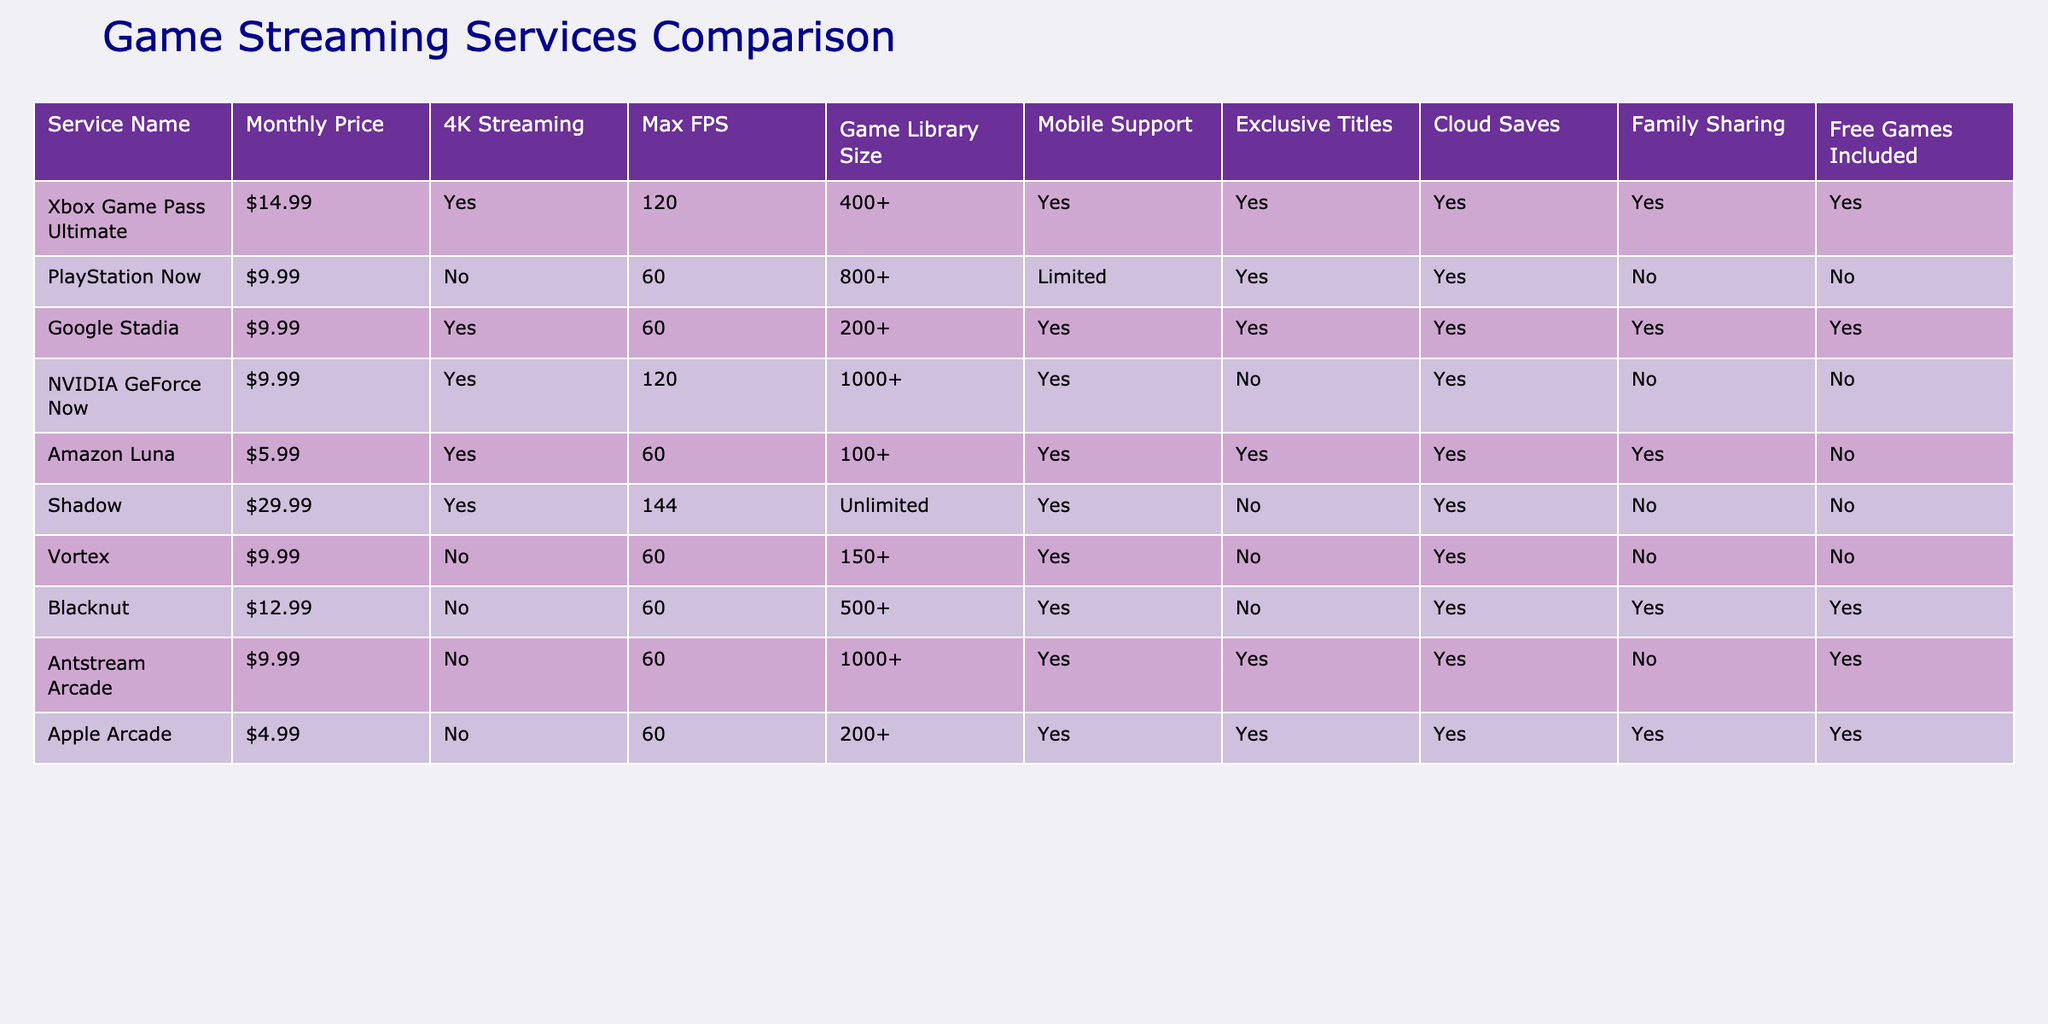What is the monthly price of NVIDIA GeForce Now? The table shows the monthly price for each service. According to the table, NVIDIA GeForce Now is listed at $9.99.
Answer: $9.99 Which service offers the largest game library size? The table provides the game library size for each service. By comparing the values, PlayStation Now has the largest game library with 800+.
Answer: PlayStation Now Does Amazon Luna support family sharing? Looking at the column for family sharing, it indicates whether each service supports this feature. Amazon Luna is marked with a "No", meaning it does not support family sharing.
Answer: No What are the average max FPS of services that offer 4K streaming? First, identify the services that offer 4K streaming: Xbox Game Pass Ultimate, Google Stadia, NVIDIA GeForce Now, and Shadow. Their max FPS are 120, 60, 120, and 144, respectively. The total FPS is 120 + 60 + 120 + 144 = 444. Since there are 4 services, the average max FPS = 444 / 4 = 111.
Answer: 111 Are there any services with mobile support that include free games? By analyzing the table, services like Xbox Game Pass Ultimate, Google Stadia, Amazon Luna, Antstream Arcade, and Apple Arcade have mobile support. Out of these, Xbox Game Pass Ultimate, Google Stadia, and Antstream Arcade offer free games. Therefore, there are services with mobile support that include free games.
Answer: Yes What is the price difference between Shadow and Apple Arcade? The monthly price for Shadow is $29.99, while for Apple Arcade, it is $4.99. The price difference is calculated as $29.99 - $4.99 = $25.00.
Answer: $25.00 How many services support 4K streaming? To determine this, we check the 4K streaming column. The services that support it are Xbox Game Pass Ultimate, Google Stadia, NVIDIA GeForce Now, Amazon Luna, and Shadow, totaling 5.
Answer: 5 Which service has the maximum FPS, and what is it? Looking through the max FPS column, Shadow has the highest max FPS listed at 144. Thus, Shadow offers the maximum FPS in the table.
Answer: Shadow, 144 Is there a service that offers both exclusive titles and cloud saves? By reviewing the exclusive titles and cloud saves columns, Xbox Game Pass Ultimate and Antstream Arcade are the only two services that provide both features. Therefore, there are services that meet this criterion.
Answer: Yes 